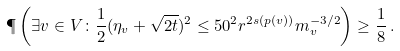<formula> <loc_0><loc_0><loc_500><loc_500>\P \left ( \exists v \in V \colon \frac { 1 } { 2 } ( \eta _ { v } + \sqrt { 2 t } ) ^ { 2 } \leq 5 0 ^ { 2 } r ^ { 2 s ( p ( v ) ) } m _ { v } ^ { - 3 / 2 } \right ) \geq \frac { 1 } { 8 } \, .</formula> 